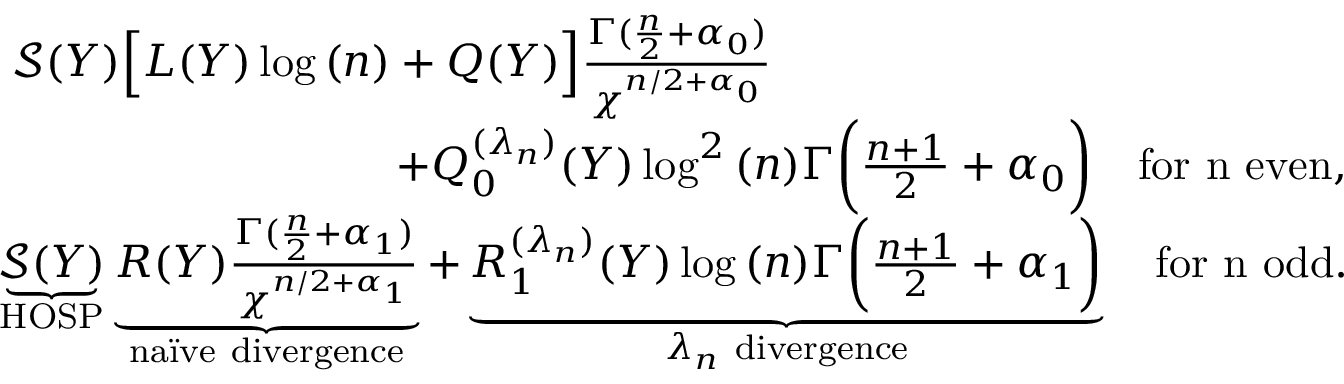Convert formula to latex. <formula><loc_0><loc_0><loc_500><loc_500>\begin{array} { r l } & { \mathcal { S } ( Y ) \left [ L ( Y ) \log { ( n ) } + Q ( Y ) \right ] \frac { \Gamma ( \frac { n } { 2 } + \alpha _ { 0 } ) } { \chi ^ { n / 2 + \alpha _ { 0 } } } \quad } \\ & { \quad + Q _ { 0 } ^ { ( \lambda _ { n } ) } ( Y ) \log ^ { 2 } { ( n ) } \Gamma \left ( \frac { n + 1 } { 2 } + \alpha _ { 0 } \right ) \quad f o r n e v e n , } \\ & { \underbrace { \mathcal { S } ( Y ) } _ { H O S P } \underbrace { R ( Y ) \frac { \Gamma ( \frac { n } { 2 } + \alpha _ { 1 } ) } { \chi ^ { n / 2 + \alpha _ { 1 } } } } _ { n a \ " i v e d i v e r g e n c e } + \underbrace { R _ { 1 } ^ { ( \lambda _ { n } ) } ( Y ) \log { ( n ) } \Gamma \left ( \frac { n + 1 } { 2 } + \alpha _ { 1 } \right ) } _ { { \lambda _ { n } d i v e r g e n c e } } \quad f o r n o d d . } \end{array}</formula> 